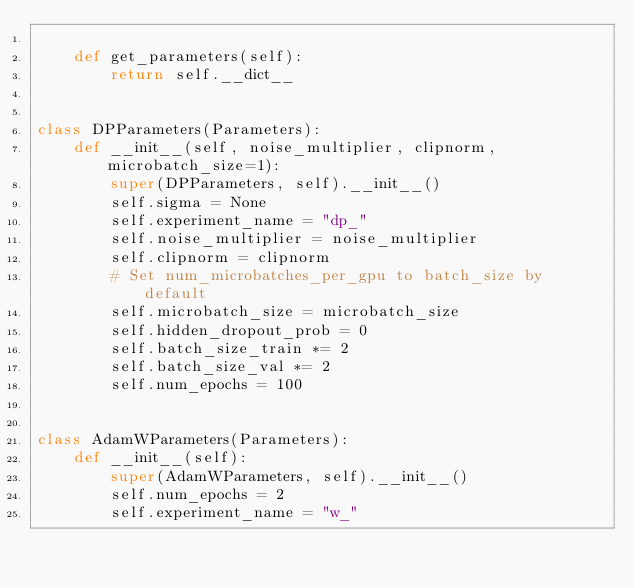<code> <loc_0><loc_0><loc_500><loc_500><_Python_>
    def get_parameters(self):
        return self.__dict__


class DPParameters(Parameters):
    def __init__(self, noise_multiplier, clipnorm, microbatch_size=1):
        super(DPParameters, self).__init__()
        self.sigma = None
        self.experiment_name = "dp_"
        self.noise_multiplier = noise_multiplier
        self.clipnorm = clipnorm
        # Set num_microbatches_per_gpu to batch_size by default
        self.microbatch_size = microbatch_size
        self.hidden_dropout_prob = 0
        self.batch_size_train *= 2
        self.batch_size_val *= 2
        self.num_epochs = 100


class AdamWParameters(Parameters):
    def __init__(self):
        super(AdamWParameters, self).__init__()
        self.num_epochs = 2
        self.experiment_name = "w_"
</code> 